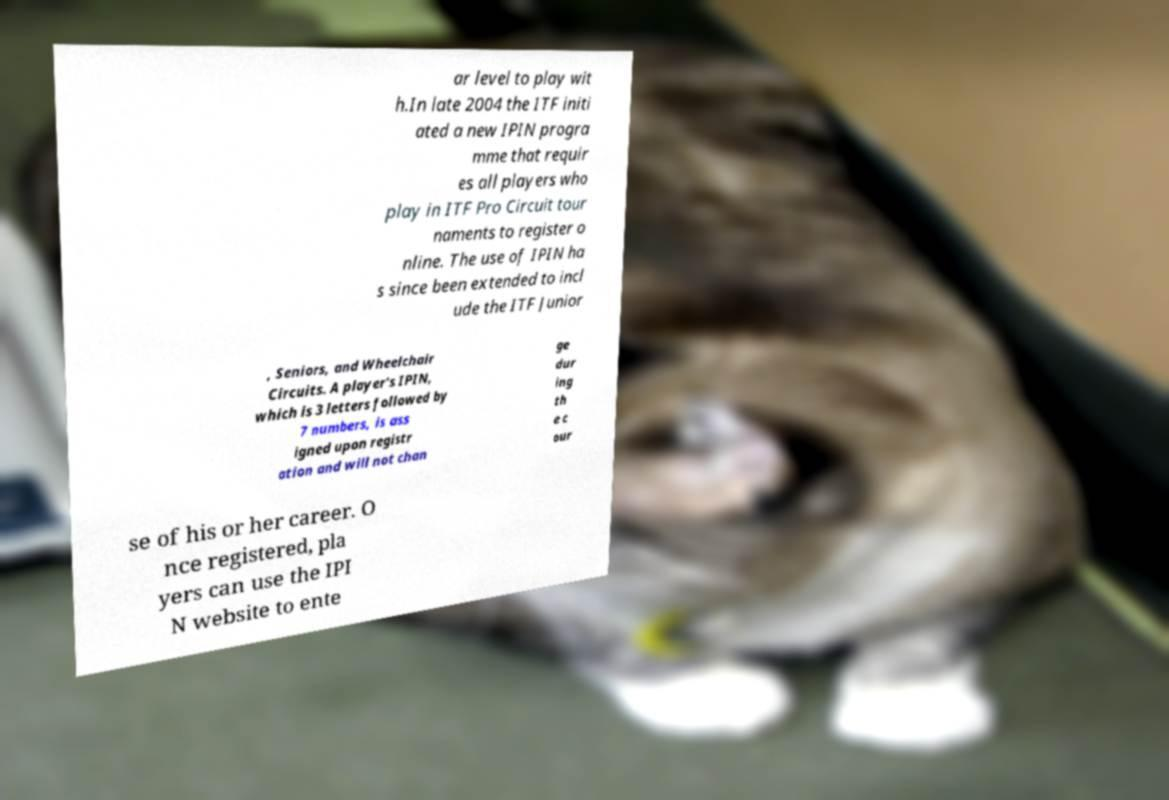Please identify and transcribe the text found in this image. ar level to play wit h.In late 2004 the ITF initi ated a new IPIN progra mme that requir es all players who play in ITF Pro Circuit tour naments to register o nline. The use of IPIN ha s since been extended to incl ude the ITF Junior , Seniors, and Wheelchair Circuits. A player's IPIN, which is 3 letters followed by 7 numbers, is ass igned upon registr ation and will not chan ge dur ing th e c our se of his or her career. O nce registered, pla yers can use the IPI N website to ente 